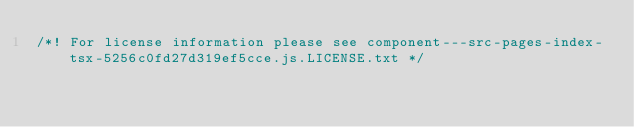<code> <loc_0><loc_0><loc_500><loc_500><_JavaScript_>/*! For license information please see component---src-pages-index-tsx-5256c0fd27d319ef5cce.js.LICENSE.txt */</code> 